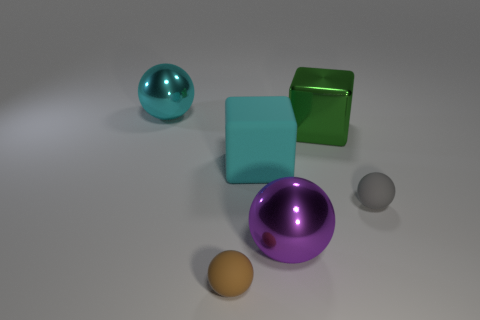Add 4 small matte spheres. How many objects exist? 10 Subtract all blocks. How many objects are left? 4 Add 1 small gray objects. How many small gray objects exist? 2 Subtract 0 blue spheres. How many objects are left? 6 Subtract all balls. Subtract all gray matte things. How many objects are left? 1 Add 6 green metallic cubes. How many green metallic cubes are left? 7 